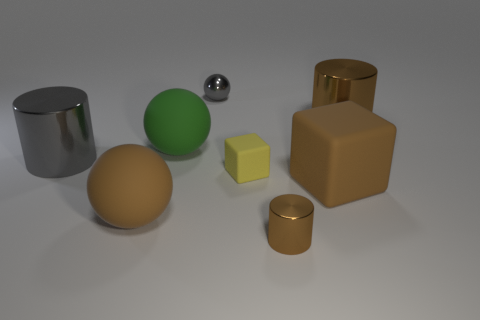How many spheres are small rubber objects or small purple metallic things?
Ensure brevity in your answer.  0. Is the number of tiny brown metal cylinders that are on the left side of the tiny gray shiny thing the same as the number of tiny green metal objects?
Offer a very short reply. Yes. What is the material of the brown ball in front of the big metal thing that is right of the large rubber sphere in front of the green matte object?
Your answer should be compact. Rubber. There is a sphere that is the same color as the small cylinder; what is it made of?
Provide a short and direct response. Rubber. What number of things are either small objects that are behind the green matte thing or gray cylinders?
Offer a very short reply. 2. How many objects are either tiny brown metallic cylinders or shiny cylinders that are left of the green rubber sphere?
Provide a short and direct response. 2. What number of green balls are in front of the ball that is in front of the large cylinder to the left of the tiny block?
Offer a very short reply. 0. There is a brown cylinder that is the same size as the green matte thing; what is its material?
Your answer should be compact. Metal. Is there a object that has the same size as the gray shiny cylinder?
Offer a very short reply. Yes. What color is the small cube?
Give a very brief answer. Yellow. 